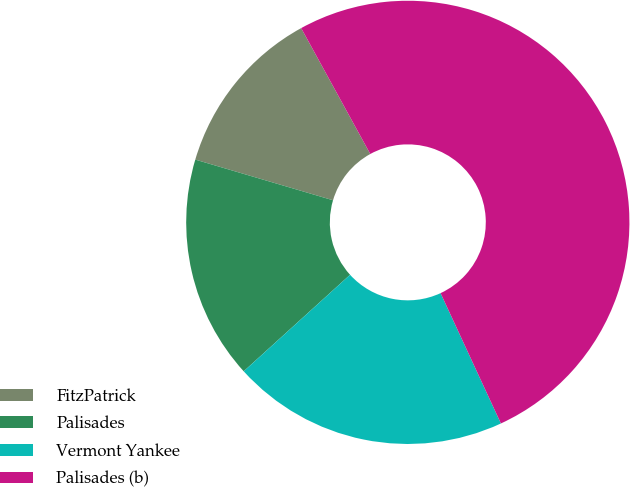Convert chart to OTSL. <chart><loc_0><loc_0><loc_500><loc_500><pie_chart><fcel>FitzPatrick<fcel>Palisades<fcel>Vermont Yankee<fcel>Palisades (b)<nl><fcel>12.44%<fcel>16.3%<fcel>20.17%<fcel>51.09%<nl></chart> 